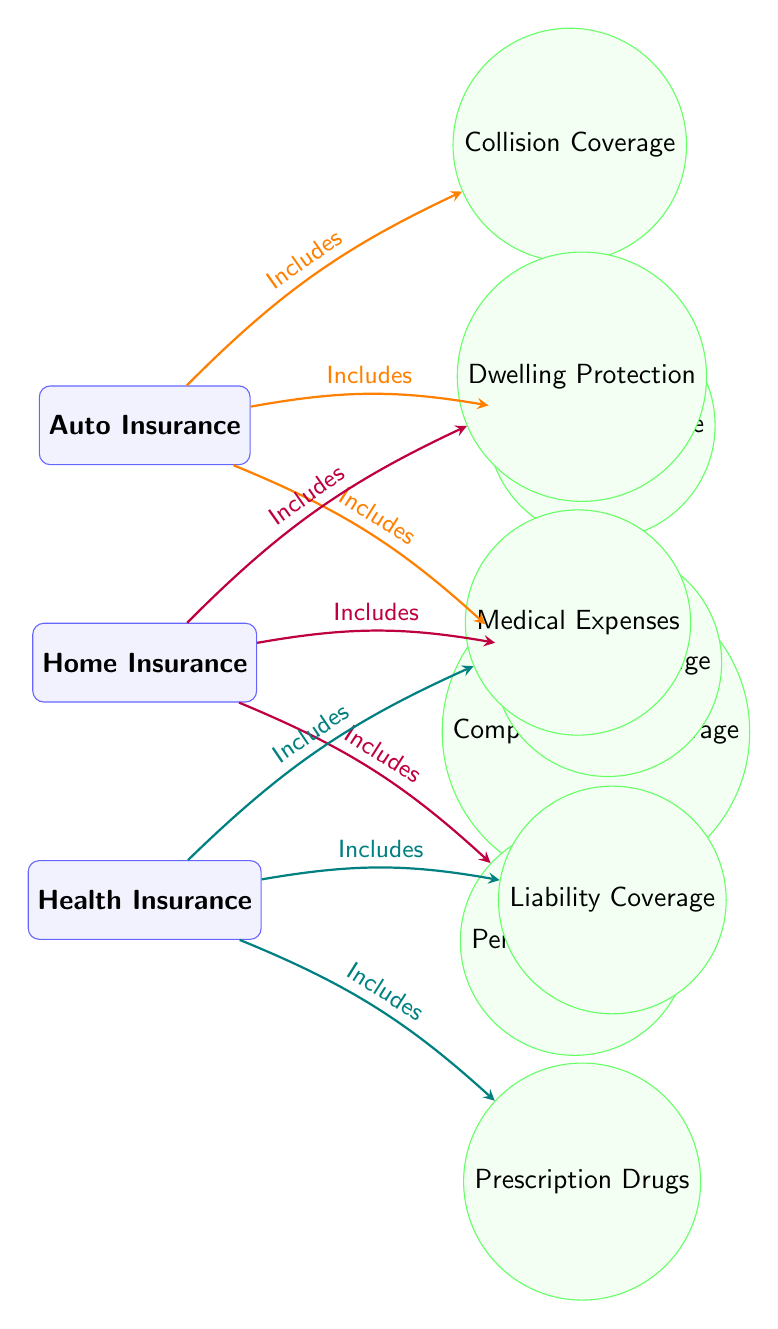What type of insurance is at the top of the diagram? The topmost node in the diagram is "Auto Insurance," indicating it is the first type of insurance visually represented.
Answer: Auto Insurance How many types of insurance policies are shown in the diagram? The diagram displays three types of insurance policies: Auto, Home, and Health. By counting these individual nodes, we find there are three.
Answer: 3 What coverage does Health Insurance include besides Liability Coverage? The Health Insurance node includes "Medical Expenses" and "Prescription Drugs" in addition to Liability Coverage. Thus, the other two coverages represent the additional inclusions.
Answer: Medical Expenses, Prescription Drugs Which insurance policy has the coverage "Dwelling Protection"? The "Dwelling Protection" coverage is connected to the "Home Insurance" node, showing that it is included in this particular insurance policy.
Answer: Home Insurance What color are the arrows representing inclusion relationships in the Home Insurance section? The arrows connected to the Home Insurance section are colored purple, which visually differentiates this section's linkages from those of other insurance types.
Answer: Purple What is the relationship between Auto Insurance and Liability Coverage? The diagram illustrates an "Includes" relationship from the Auto Insurance node to Liability Coverage, meaning that Liability Coverage is a part of what Auto Insurance encompasses.
Answer: Includes Which coverage is unique to Health Insurance among the policies shown? The "Medical Expenses" coverage is unique to the Health Insurance policy as it does not appear in the other types of insurance policies represented.
Answer: Medical Expenses How many coverage types are associated with Home Insurance? The Home Insurance node connects to three coverage types: Liability Coverage, Dwelling Protection, and Personal Property, indicating that it encompasses all three.
Answer: 3 